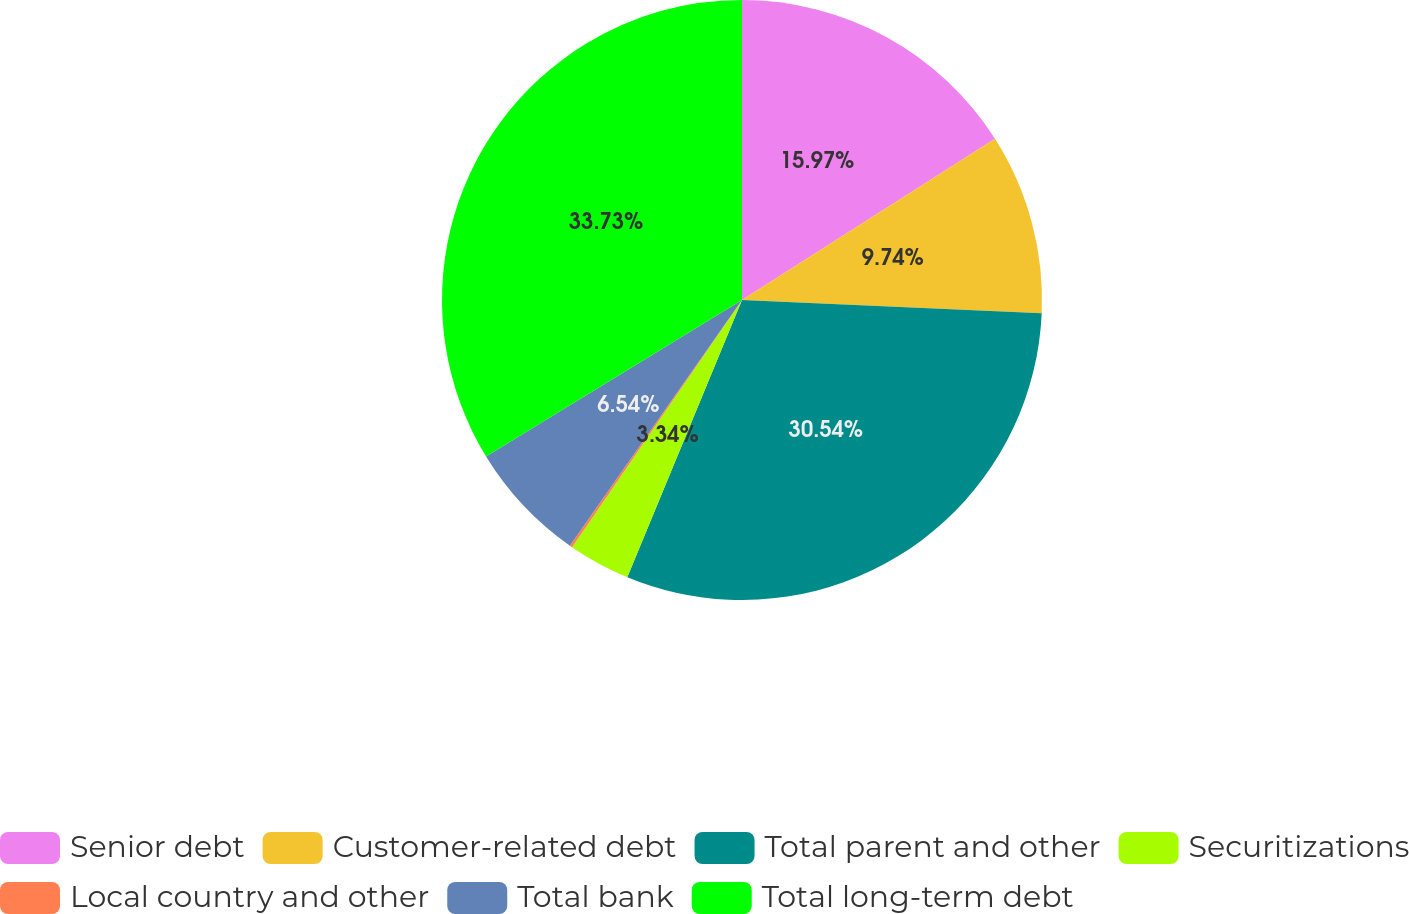Convert chart to OTSL. <chart><loc_0><loc_0><loc_500><loc_500><pie_chart><fcel>Senior debt<fcel>Customer-related debt<fcel>Total parent and other<fcel>Securitizations<fcel>Local country and other<fcel>Total bank<fcel>Total long-term debt<nl><fcel>15.97%<fcel>9.74%<fcel>30.54%<fcel>3.34%<fcel>0.14%<fcel>6.54%<fcel>33.74%<nl></chart> 